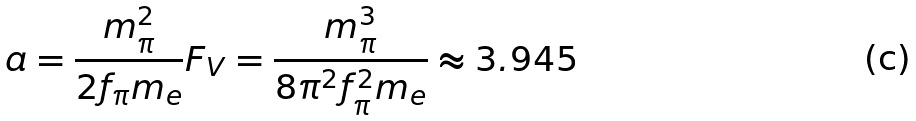Convert formula to latex. <formula><loc_0><loc_0><loc_500><loc_500>a = \frac { m ^ { 2 } _ { \pi } } { 2 f _ { \pi } m _ { e } } F _ { V } = \frac { m ^ { 3 } _ { \pi } } { 8 \pi ^ { 2 } f ^ { 2 } _ { \pi } m _ { e } } \approx 3 . 9 4 5</formula> 